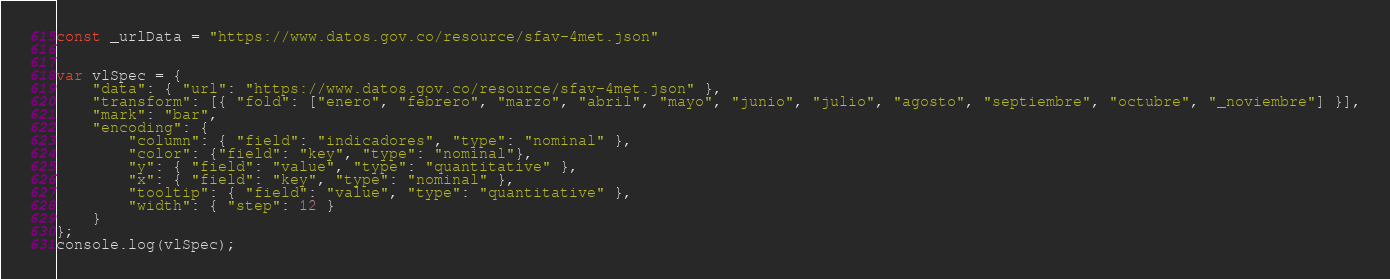Convert code to text. <code><loc_0><loc_0><loc_500><loc_500><_JavaScript_>const _urlData = "https://www.datos.gov.co/resource/sfav-4met.json"


var vlSpec = {
    "data": { "url": "https://www.datos.gov.co/resource/sfav-4met.json" },
    "transform": [{ "fold": ["enero", "febrero", "marzo", "abril", "mayo", "junio", "julio", "agosto", "septiembre", "octubre", "_noviembre"] }],
    "mark": "bar",
    "encoding": {
        "column": { "field": "indicadores", "type": "nominal" },
        "color": {"field": "key", "type": "nominal"},
        "y": { "field": "value", "type": "quantitative" },
        "x": { "field": "key", "type": "nominal" },
        "tooltip": { "field": "value", "type": "quantitative" },
        "width": { "step": 12 }
    }
};
console.log(vlSpec);</code> 